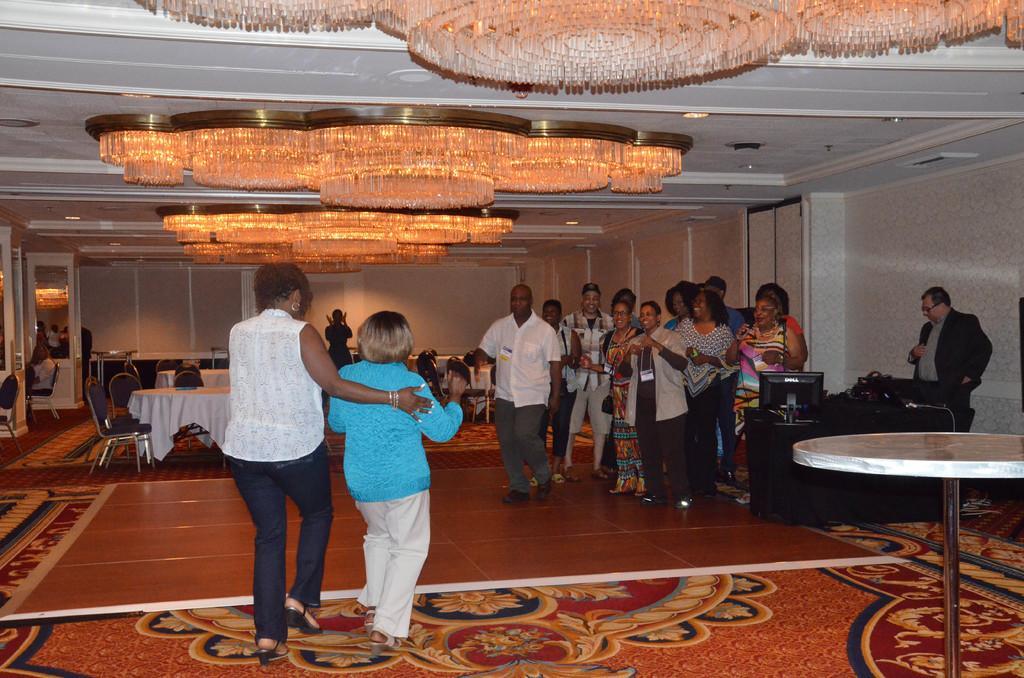Describe this image in one or two sentences. A floor with carpet. We can able to see tables, chairs and on top there are lights. These persons are standing. On this table there is a monitor. 